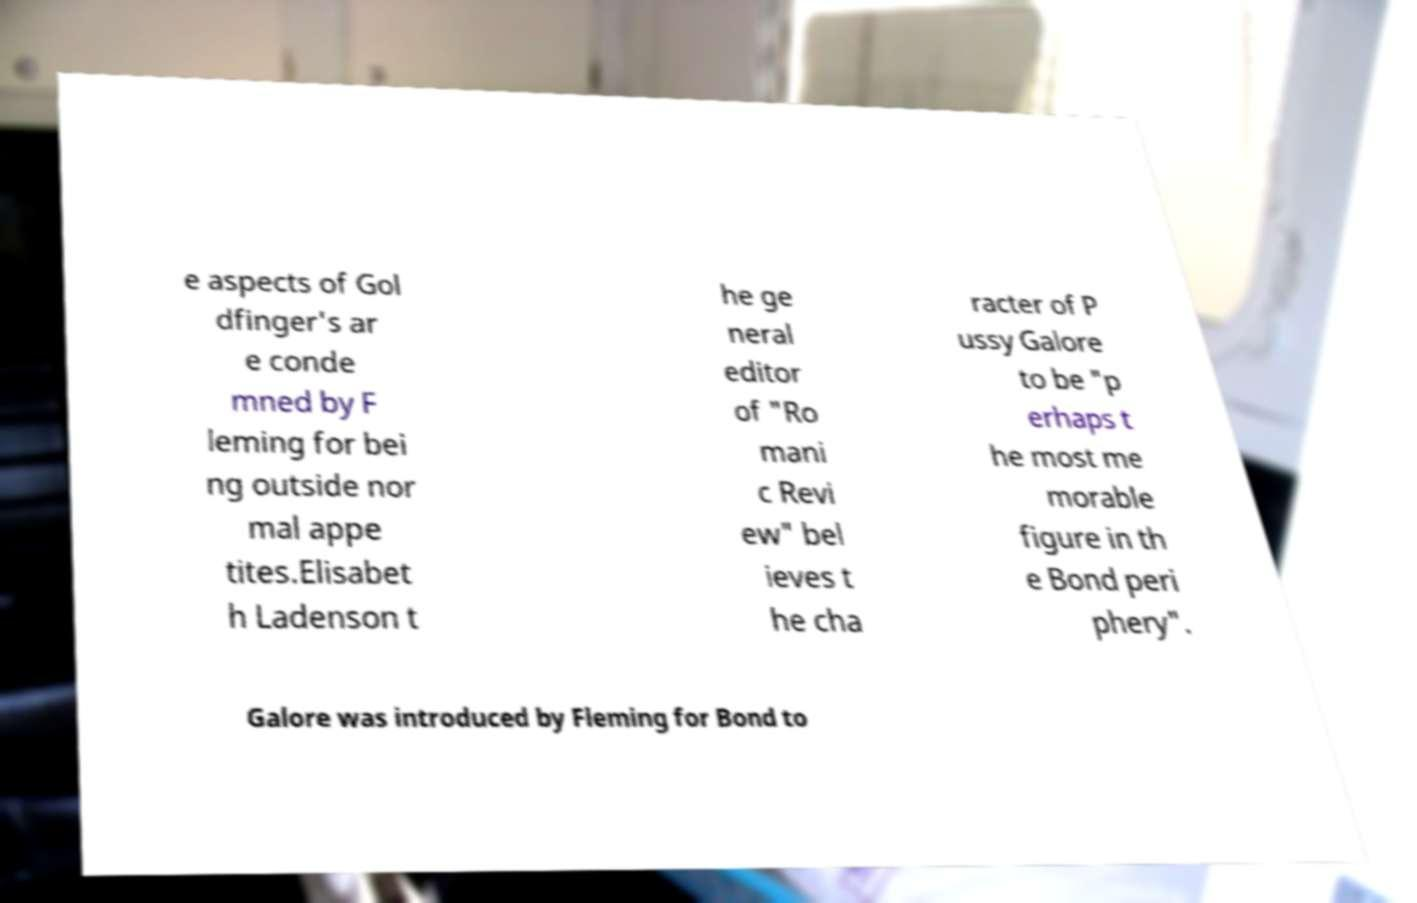Could you extract and type out the text from this image? e aspects of Gol dfinger's ar e conde mned by F leming for bei ng outside nor mal appe tites.Elisabet h Ladenson t he ge neral editor of "Ro mani c Revi ew" bel ieves t he cha racter of P ussy Galore to be "p erhaps t he most me morable figure in th e Bond peri phery". Galore was introduced by Fleming for Bond to 